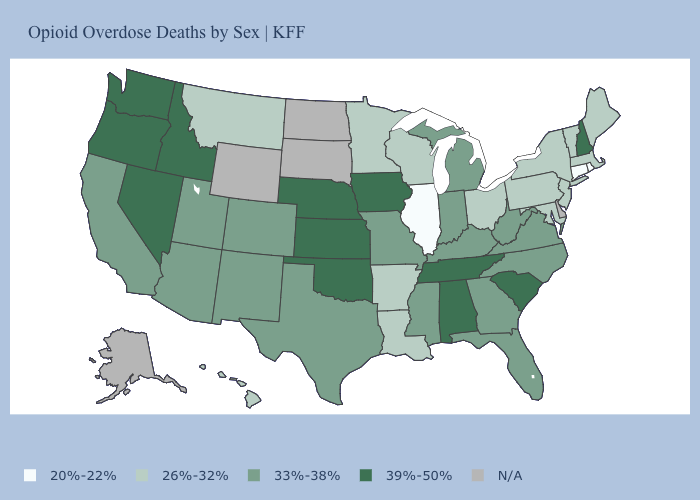How many symbols are there in the legend?
Write a very short answer. 5. Among the states that border Mississippi , does Alabama have the highest value?
Answer briefly. Yes. What is the value of Delaware?
Write a very short answer. N/A. Does Washington have the highest value in the West?
Answer briefly. Yes. What is the value of Iowa?
Keep it brief. 39%-50%. Which states have the lowest value in the MidWest?
Be succinct. Illinois. What is the value of South Carolina?
Short answer required. 39%-50%. Which states hav the highest value in the Northeast?
Short answer required. New Hampshire. Among the states that border New York , does Connecticut have the lowest value?
Concise answer only. Yes. What is the value of Kansas?
Concise answer only. 39%-50%. Is the legend a continuous bar?
Short answer required. No. Name the states that have a value in the range 33%-38%?
Quick response, please. Arizona, California, Colorado, Florida, Georgia, Indiana, Kentucky, Michigan, Mississippi, Missouri, New Mexico, North Carolina, Texas, Utah, Virginia, West Virginia. 